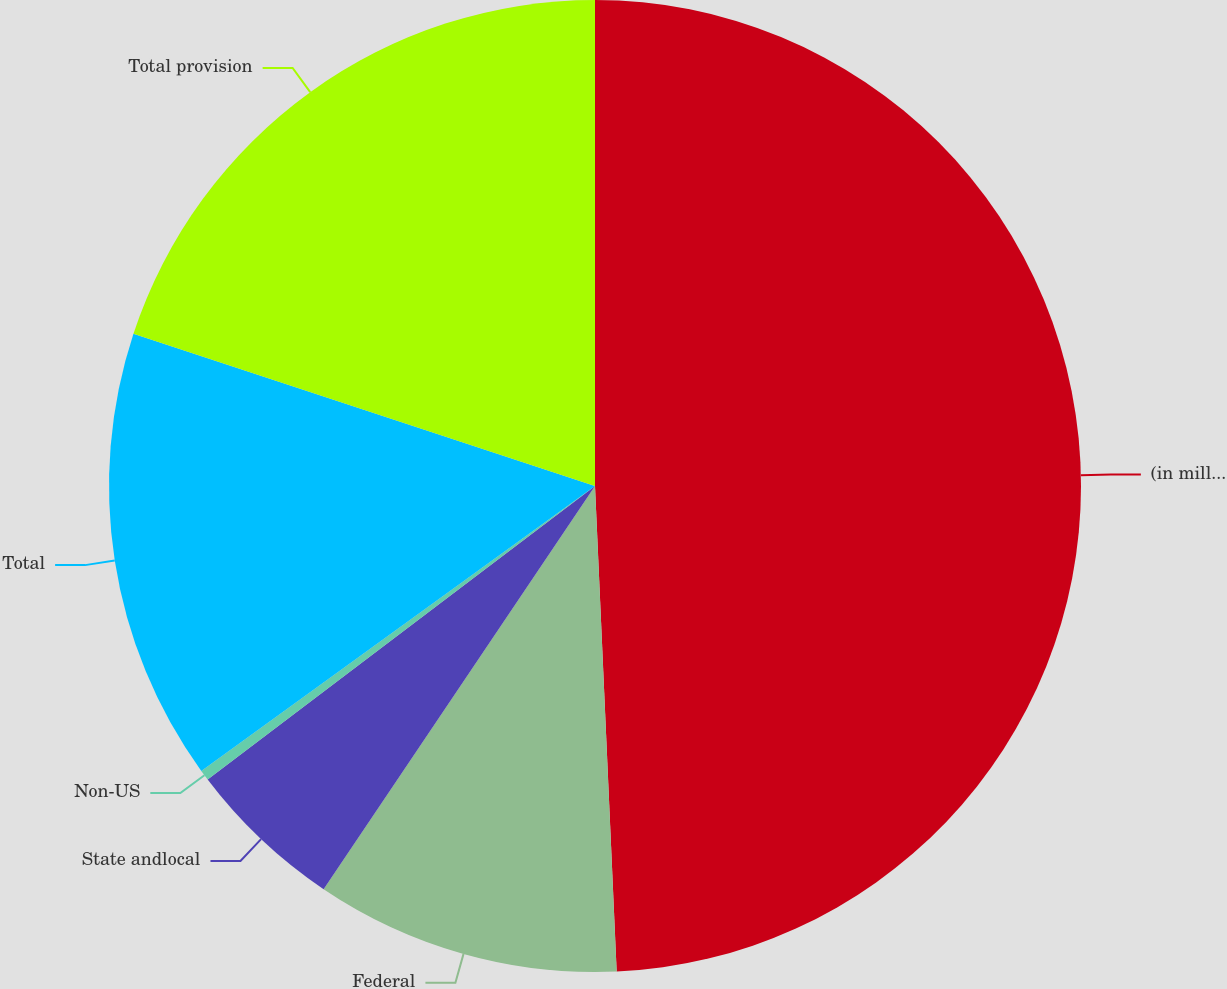Convert chart to OTSL. <chart><loc_0><loc_0><loc_500><loc_500><pie_chart><fcel>(in millions)<fcel>Federal<fcel>State andlocal<fcel>Non-US<fcel>Total<fcel>Total provision<nl><fcel>49.29%<fcel>10.14%<fcel>5.25%<fcel>0.35%<fcel>15.04%<fcel>19.93%<nl></chart> 